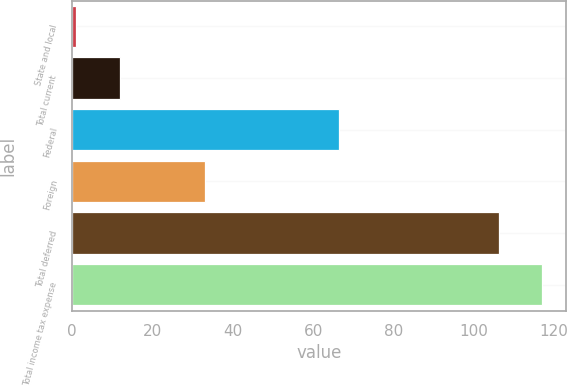Convert chart. <chart><loc_0><loc_0><loc_500><loc_500><bar_chart><fcel>State and local<fcel>Total current<fcel>Federal<fcel>Foreign<fcel>Total deferred<fcel>Total income tax expense<nl><fcel>1<fcel>11.82<fcel>66.4<fcel>33.1<fcel>106.2<fcel>117.02<nl></chart> 